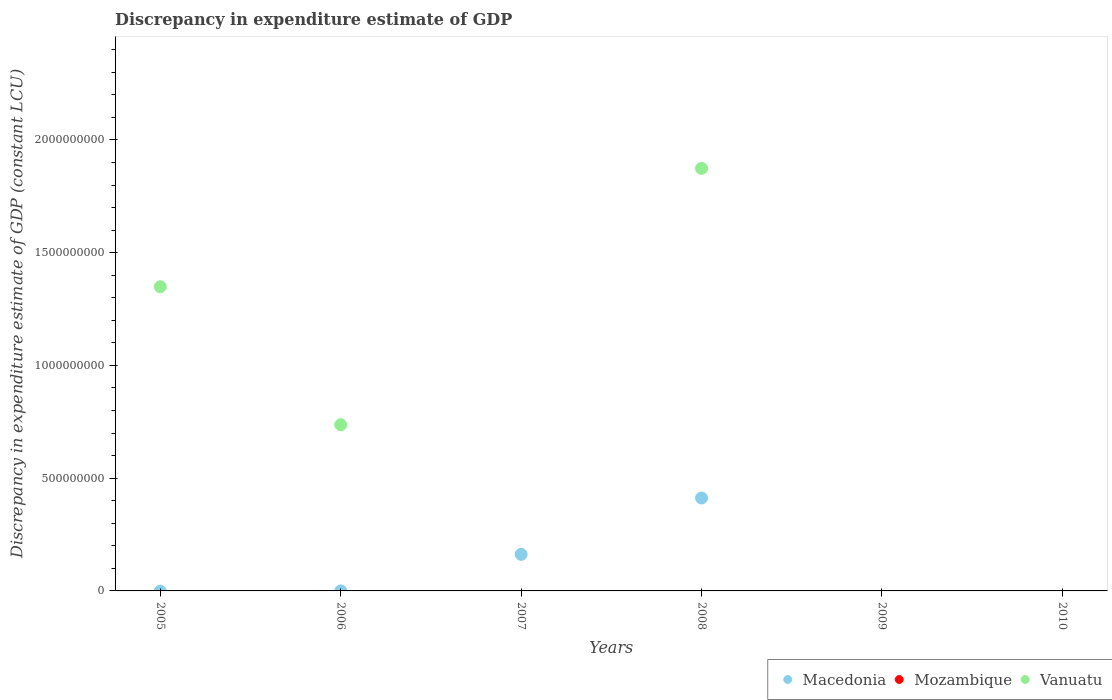How many different coloured dotlines are there?
Provide a succinct answer. 2. Is the number of dotlines equal to the number of legend labels?
Your answer should be very brief. No. What is the discrepancy in expenditure estimate of GDP in Vanuatu in 2006?
Your response must be concise. 7.37e+08. Across all years, what is the maximum discrepancy in expenditure estimate of GDP in Vanuatu?
Ensure brevity in your answer.  1.87e+09. What is the total discrepancy in expenditure estimate of GDP in Vanuatu in the graph?
Your response must be concise. 3.96e+09. What is the difference between the discrepancy in expenditure estimate of GDP in Macedonia in 2007 and the discrepancy in expenditure estimate of GDP in Vanuatu in 2010?
Keep it short and to the point. 1.62e+08. What is the average discrepancy in expenditure estimate of GDP in Vanuatu per year?
Make the answer very short. 6.60e+08. In the year 2006, what is the difference between the discrepancy in expenditure estimate of GDP in Vanuatu and discrepancy in expenditure estimate of GDP in Macedonia?
Offer a terse response. 7.37e+08. In how many years, is the discrepancy in expenditure estimate of GDP in Vanuatu greater than 1000000000 LCU?
Provide a short and direct response. 2. What is the ratio of the discrepancy in expenditure estimate of GDP in Vanuatu in 2005 to that in 2008?
Offer a terse response. 0.72. What is the difference between the highest and the second highest discrepancy in expenditure estimate of GDP in Vanuatu?
Provide a short and direct response. 5.25e+08. What is the difference between the highest and the lowest discrepancy in expenditure estimate of GDP in Vanuatu?
Make the answer very short. 1.87e+09. Is the sum of the discrepancy in expenditure estimate of GDP in Macedonia in 2007 and 2008 greater than the maximum discrepancy in expenditure estimate of GDP in Vanuatu across all years?
Make the answer very short. No. Is it the case that in every year, the sum of the discrepancy in expenditure estimate of GDP in Vanuatu and discrepancy in expenditure estimate of GDP in Mozambique  is greater than the discrepancy in expenditure estimate of GDP in Macedonia?
Provide a succinct answer. No. Does the discrepancy in expenditure estimate of GDP in Vanuatu monotonically increase over the years?
Provide a succinct answer. No. Is the discrepancy in expenditure estimate of GDP in Macedonia strictly less than the discrepancy in expenditure estimate of GDP in Mozambique over the years?
Keep it short and to the point. No. How many dotlines are there?
Keep it short and to the point. 2. What is the difference between two consecutive major ticks on the Y-axis?
Your answer should be very brief. 5.00e+08. Are the values on the major ticks of Y-axis written in scientific E-notation?
Keep it short and to the point. No. Does the graph contain grids?
Make the answer very short. No. Where does the legend appear in the graph?
Give a very brief answer. Bottom right. What is the title of the graph?
Offer a very short reply. Discrepancy in expenditure estimate of GDP. What is the label or title of the X-axis?
Keep it short and to the point. Years. What is the label or title of the Y-axis?
Provide a succinct answer. Discrepancy in expenditure estimate of GDP (constant LCU). What is the Discrepancy in expenditure estimate of GDP (constant LCU) in Macedonia in 2005?
Your answer should be compact. 0. What is the Discrepancy in expenditure estimate of GDP (constant LCU) of Vanuatu in 2005?
Make the answer very short. 1.35e+09. What is the Discrepancy in expenditure estimate of GDP (constant LCU) in Macedonia in 2006?
Provide a succinct answer. 4.69e+04. What is the Discrepancy in expenditure estimate of GDP (constant LCU) of Mozambique in 2006?
Your response must be concise. 0. What is the Discrepancy in expenditure estimate of GDP (constant LCU) of Vanuatu in 2006?
Your response must be concise. 7.37e+08. What is the Discrepancy in expenditure estimate of GDP (constant LCU) in Macedonia in 2007?
Provide a short and direct response. 1.62e+08. What is the Discrepancy in expenditure estimate of GDP (constant LCU) of Mozambique in 2007?
Provide a succinct answer. 0. What is the Discrepancy in expenditure estimate of GDP (constant LCU) in Vanuatu in 2007?
Ensure brevity in your answer.  0. What is the Discrepancy in expenditure estimate of GDP (constant LCU) in Macedonia in 2008?
Make the answer very short. 4.12e+08. What is the Discrepancy in expenditure estimate of GDP (constant LCU) in Vanuatu in 2008?
Ensure brevity in your answer.  1.87e+09. What is the Discrepancy in expenditure estimate of GDP (constant LCU) of Macedonia in 2010?
Offer a very short reply. 0. What is the Discrepancy in expenditure estimate of GDP (constant LCU) of Vanuatu in 2010?
Give a very brief answer. 0. Across all years, what is the maximum Discrepancy in expenditure estimate of GDP (constant LCU) in Macedonia?
Provide a short and direct response. 4.12e+08. Across all years, what is the maximum Discrepancy in expenditure estimate of GDP (constant LCU) of Vanuatu?
Give a very brief answer. 1.87e+09. Across all years, what is the minimum Discrepancy in expenditure estimate of GDP (constant LCU) of Macedonia?
Offer a terse response. 0. What is the total Discrepancy in expenditure estimate of GDP (constant LCU) in Macedonia in the graph?
Your answer should be very brief. 5.74e+08. What is the total Discrepancy in expenditure estimate of GDP (constant LCU) in Mozambique in the graph?
Ensure brevity in your answer.  0. What is the total Discrepancy in expenditure estimate of GDP (constant LCU) in Vanuatu in the graph?
Ensure brevity in your answer.  3.96e+09. What is the difference between the Discrepancy in expenditure estimate of GDP (constant LCU) in Vanuatu in 2005 and that in 2006?
Make the answer very short. 6.12e+08. What is the difference between the Discrepancy in expenditure estimate of GDP (constant LCU) in Vanuatu in 2005 and that in 2008?
Offer a terse response. -5.25e+08. What is the difference between the Discrepancy in expenditure estimate of GDP (constant LCU) of Macedonia in 2006 and that in 2007?
Your answer should be very brief. -1.62e+08. What is the difference between the Discrepancy in expenditure estimate of GDP (constant LCU) of Macedonia in 2006 and that in 2008?
Provide a short and direct response. -4.12e+08. What is the difference between the Discrepancy in expenditure estimate of GDP (constant LCU) of Vanuatu in 2006 and that in 2008?
Offer a very short reply. -1.14e+09. What is the difference between the Discrepancy in expenditure estimate of GDP (constant LCU) in Macedonia in 2007 and that in 2008?
Your response must be concise. -2.50e+08. What is the difference between the Discrepancy in expenditure estimate of GDP (constant LCU) of Macedonia in 2006 and the Discrepancy in expenditure estimate of GDP (constant LCU) of Vanuatu in 2008?
Ensure brevity in your answer.  -1.87e+09. What is the difference between the Discrepancy in expenditure estimate of GDP (constant LCU) in Macedonia in 2007 and the Discrepancy in expenditure estimate of GDP (constant LCU) in Vanuatu in 2008?
Your response must be concise. -1.71e+09. What is the average Discrepancy in expenditure estimate of GDP (constant LCU) in Macedonia per year?
Provide a succinct answer. 9.57e+07. What is the average Discrepancy in expenditure estimate of GDP (constant LCU) of Mozambique per year?
Make the answer very short. 0. What is the average Discrepancy in expenditure estimate of GDP (constant LCU) of Vanuatu per year?
Your answer should be compact. 6.60e+08. In the year 2006, what is the difference between the Discrepancy in expenditure estimate of GDP (constant LCU) of Macedonia and Discrepancy in expenditure estimate of GDP (constant LCU) of Vanuatu?
Give a very brief answer. -7.37e+08. In the year 2008, what is the difference between the Discrepancy in expenditure estimate of GDP (constant LCU) of Macedonia and Discrepancy in expenditure estimate of GDP (constant LCU) of Vanuatu?
Provide a short and direct response. -1.46e+09. What is the ratio of the Discrepancy in expenditure estimate of GDP (constant LCU) in Vanuatu in 2005 to that in 2006?
Ensure brevity in your answer.  1.83. What is the ratio of the Discrepancy in expenditure estimate of GDP (constant LCU) of Vanuatu in 2005 to that in 2008?
Make the answer very short. 0.72. What is the ratio of the Discrepancy in expenditure estimate of GDP (constant LCU) in Vanuatu in 2006 to that in 2008?
Provide a succinct answer. 0.39. What is the ratio of the Discrepancy in expenditure estimate of GDP (constant LCU) in Macedonia in 2007 to that in 2008?
Make the answer very short. 0.39. What is the difference between the highest and the second highest Discrepancy in expenditure estimate of GDP (constant LCU) in Macedonia?
Ensure brevity in your answer.  2.50e+08. What is the difference between the highest and the second highest Discrepancy in expenditure estimate of GDP (constant LCU) in Vanuatu?
Ensure brevity in your answer.  5.25e+08. What is the difference between the highest and the lowest Discrepancy in expenditure estimate of GDP (constant LCU) in Macedonia?
Provide a short and direct response. 4.12e+08. What is the difference between the highest and the lowest Discrepancy in expenditure estimate of GDP (constant LCU) in Vanuatu?
Your answer should be compact. 1.87e+09. 